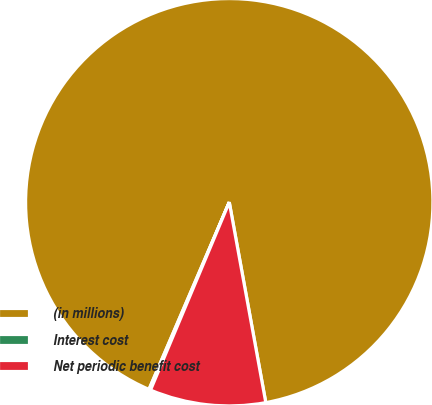Convert chart to OTSL. <chart><loc_0><loc_0><loc_500><loc_500><pie_chart><fcel>(in millions)<fcel>Interest cost<fcel>Net periodic benefit cost<nl><fcel>90.68%<fcel>0.13%<fcel>9.19%<nl></chart> 